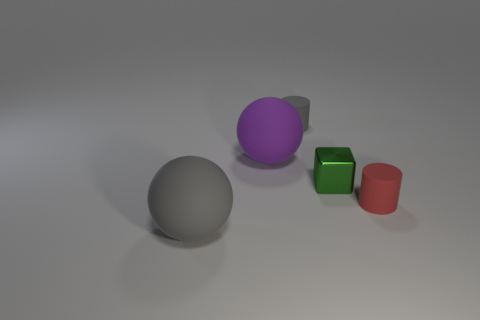Is there any other thing that has the same material as the cube?
Your answer should be very brief. No. How many other objects are there of the same material as the large purple object?
Your response must be concise. 3. Are there any red rubber things of the same shape as the small gray thing?
Keep it short and to the point. Yes. There is a purple rubber ball; is its size the same as the gray thing in front of the shiny block?
Keep it short and to the point. Yes. What number of objects are large rubber balls that are to the right of the big gray ball or tiny cylinders that are behind the block?
Make the answer very short. 2. Is the number of things that are right of the purple thing greater than the number of tiny objects?
Keep it short and to the point. No. What number of gray cylinders are the same size as the red matte object?
Give a very brief answer. 1. There is a cylinder behind the purple ball; is it the same size as the gray object that is in front of the gray rubber cylinder?
Your answer should be compact. No. How big is the rubber cylinder that is right of the shiny block?
Give a very brief answer. Small. How big is the cylinder behind the tiny cylinder that is in front of the gray rubber cylinder?
Your answer should be very brief. Small. 